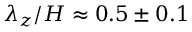<formula> <loc_0><loc_0><loc_500><loc_500>\lambda _ { z } / H \approx 0 . 5 \pm 0 . 1</formula> 